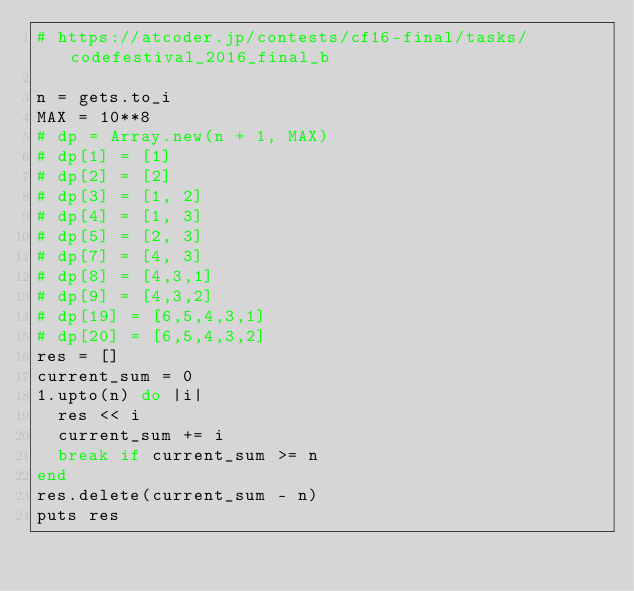<code> <loc_0><loc_0><loc_500><loc_500><_Ruby_># https://atcoder.jp/contests/cf16-final/tasks/codefestival_2016_final_b

n = gets.to_i
MAX = 10**8
# dp = Array.new(n + 1, MAX)
# dp[1] = [1]
# dp[2] = [2]
# dp[3] = [1, 2]
# dp[4] = [1, 3]
# dp[5] = [2, 3]
# dp[7] = [4, 3]
# dp[8] = [4,3,1]
# dp[9] = [4,3,2]
# dp[19] = [6,5,4,3,1]
# dp[20] = [6,5,4,3,2]
res = []
current_sum = 0
1.upto(n) do |i|
  res << i
  current_sum += i
  break if current_sum >= n
end
res.delete(current_sum - n)
puts res</code> 